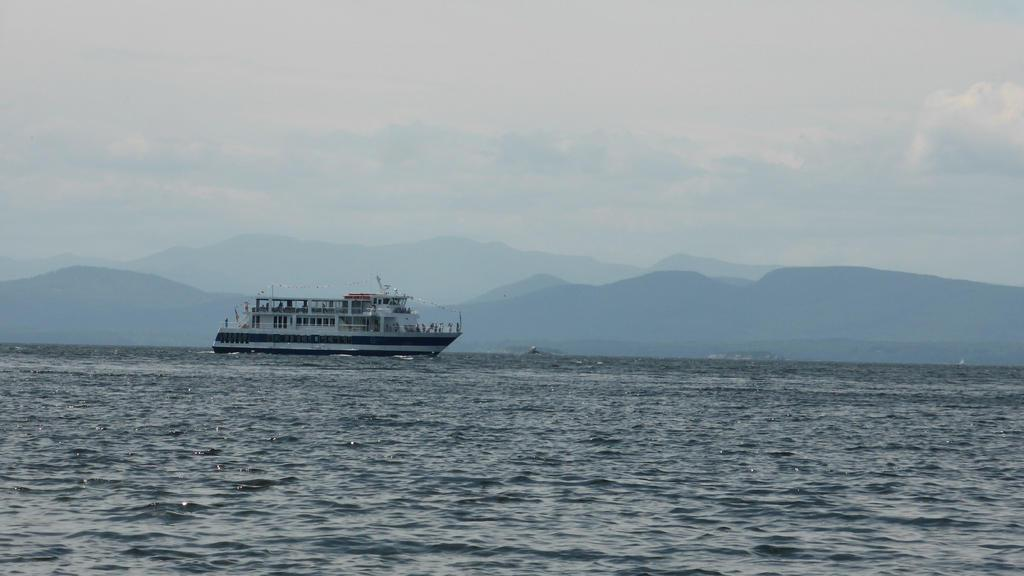What is the main subject of the image? The main subject of the image is a ship. Where is the ship located in the image? The ship is in the water. What type of landscape can be seen in the background of the image? There are mountains visible in the image. How would you describe the weather based on the image? The sky is cloudy in the image. What type of flower is growing on the ship in the image? There are no flowers visible on the ship in the image. 